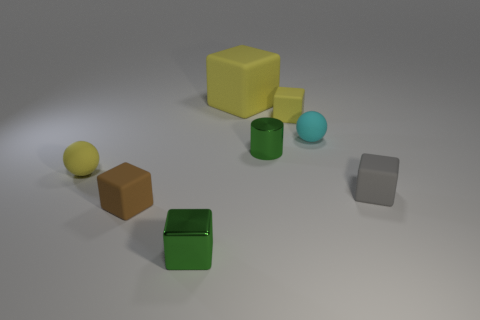Do the small shiny cylinder and the large thing have the same color?
Ensure brevity in your answer.  No. What is the shape of the thing that is the same color as the small cylinder?
Ensure brevity in your answer.  Cube. What size is the green cube that is in front of the tiny ball that is left of the large object?
Your response must be concise. Small. How many things are either small cubes on the right side of the small cyan matte object or yellow matte objects that are to the right of the brown cube?
Give a very brief answer. 3. Are there fewer tiny yellow balls than gray rubber cylinders?
Keep it short and to the point. No. What number of things are either matte balls or red metal cylinders?
Offer a very short reply. 2. Is the big rubber object the same shape as the brown matte object?
Offer a very short reply. Yes. Is there any other thing that has the same material as the small brown object?
Ensure brevity in your answer.  Yes. Does the yellow matte cube that is on the right side of the big yellow matte cube have the same size as the yellow thing that is to the left of the big matte object?
Provide a succinct answer. Yes. There is a block that is right of the small shiny cylinder and to the left of the gray cube; what is its material?
Your answer should be compact. Rubber. 